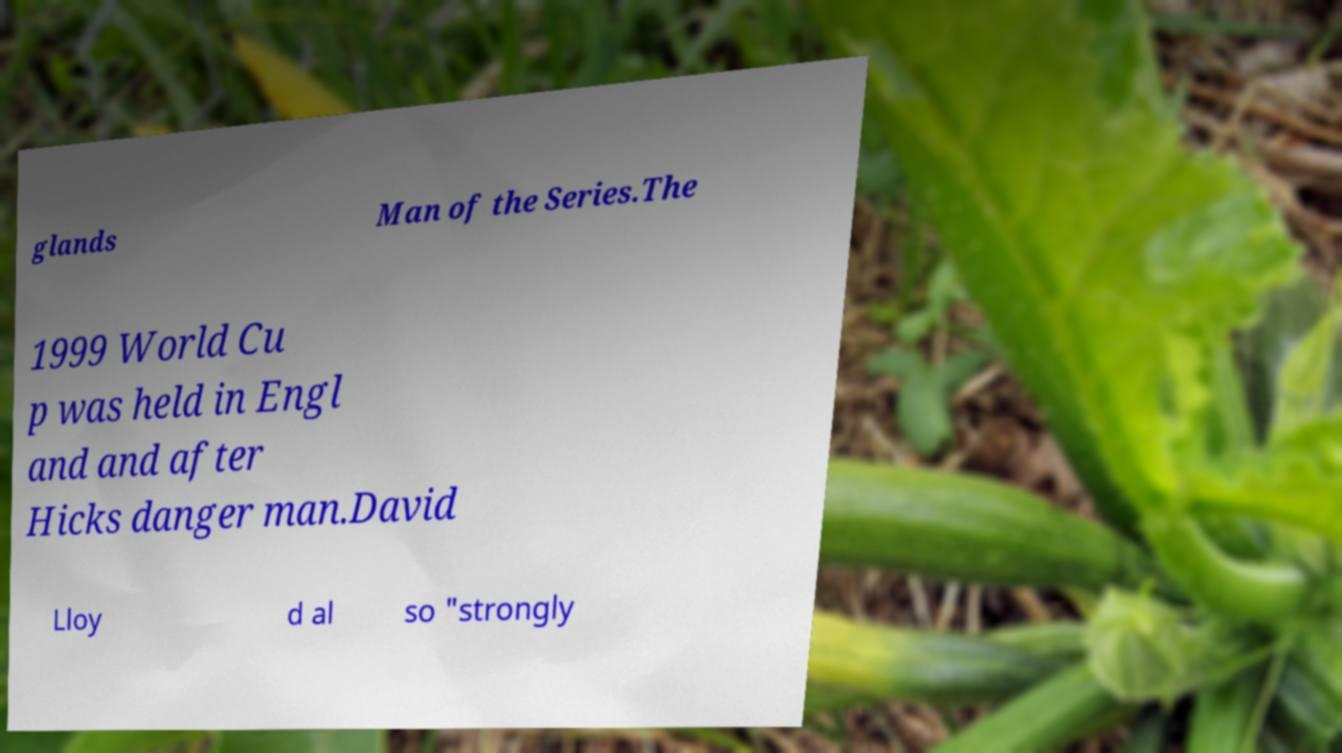I need the written content from this picture converted into text. Can you do that? glands Man of the Series.The 1999 World Cu p was held in Engl and and after Hicks danger man.David Lloy d al so "strongly 